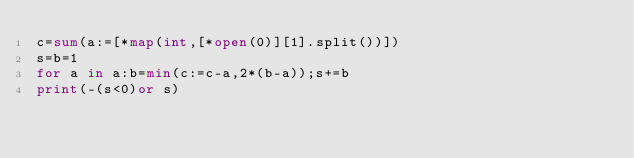<code> <loc_0><loc_0><loc_500><loc_500><_Python_>c=sum(a:=[*map(int,[*open(0)][1].split())])
s=b=1
for a in a:b=min(c:=c-a,2*(b-a));s+=b
print(-(s<0)or s)</code> 